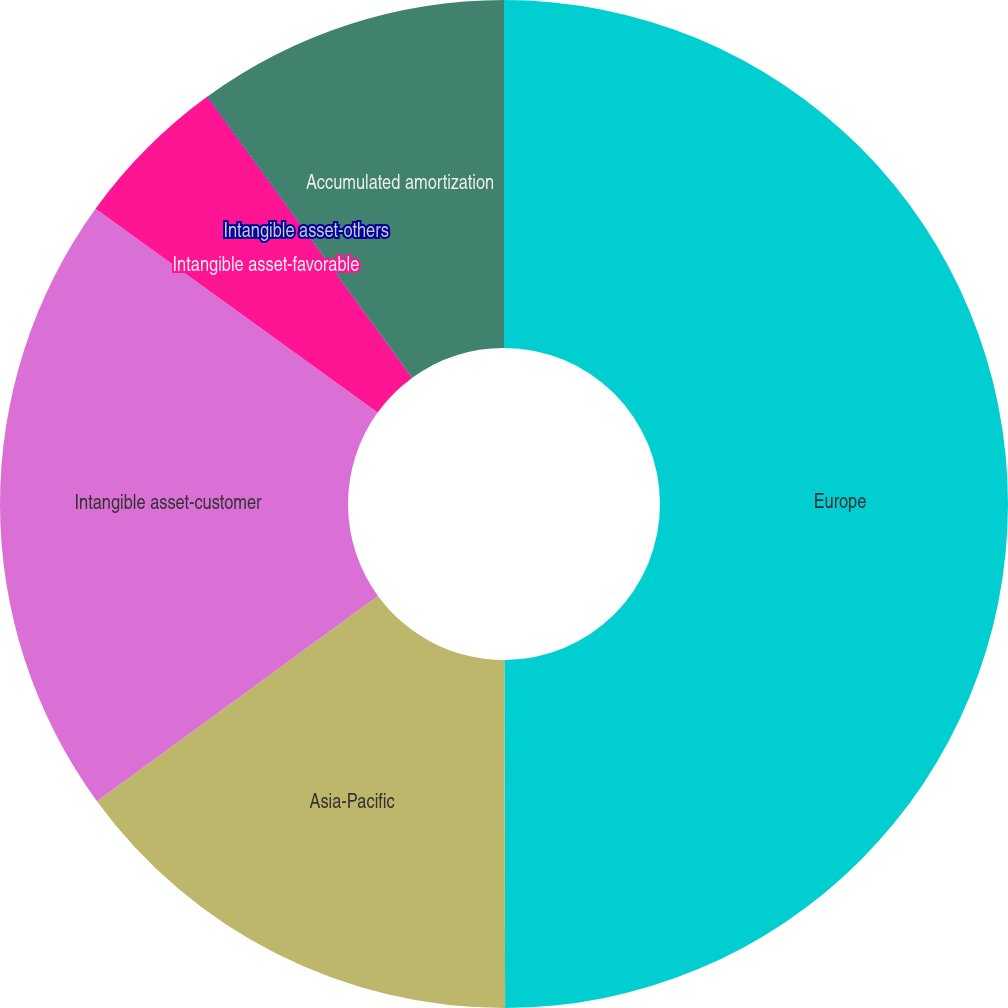Convert chart. <chart><loc_0><loc_0><loc_500><loc_500><pie_chart><fcel>Europe<fcel>Asia-Pacific<fcel>Intangible asset-customer<fcel>Intangible asset-favorable<fcel>Intangible asset-others<fcel>Accumulated amortization<nl><fcel>49.97%<fcel>15.0%<fcel>20.0%<fcel>5.01%<fcel>0.02%<fcel>10.01%<nl></chart> 